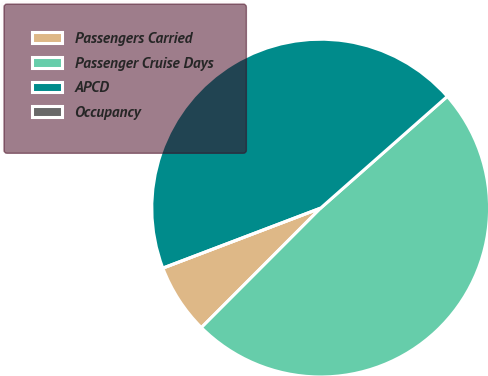<chart> <loc_0><loc_0><loc_500><loc_500><pie_chart><fcel>Passengers Carried<fcel>Passenger Cruise Days<fcel>APCD<fcel>Occupancy<nl><fcel>6.73%<fcel>48.99%<fcel>44.28%<fcel>0.0%<nl></chart> 